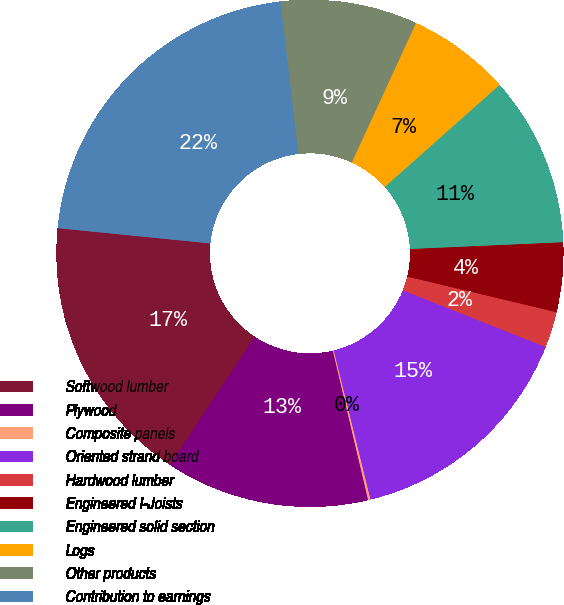Convert chart. <chart><loc_0><loc_0><loc_500><loc_500><pie_chart><fcel>Softwood lumber<fcel>Plywood<fcel>Composite panels<fcel>Oriented strand board<fcel>Hardwood lumber<fcel>Engineered I-Joists<fcel>Engineered solid section<fcel>Logs<fcel>Other products<fcel>Contribution to earnings<nl><fcel>17.28%<fcel>13.0%<fcel>0.15%<fcel>15.14%<fcel>2.29%<fcel>4.43%<fcel>10.86%<fcel>6.57%<fcel>8.72%<fcel>21.56%<nl></chart> 